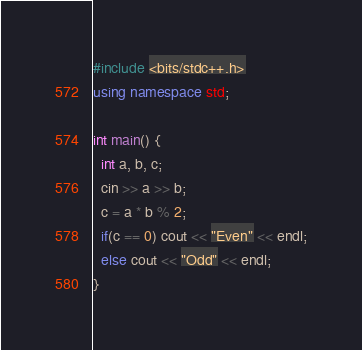<code> <loc_0><loc_0><loc_500><loc_500><_C++_>#include <bits/stdc++.h>
using namespace std;

int main() {
  int a, b, c;
  cin >> a >> b;
  c = a * b % 2;
  if(c == 0) cout << "Even" << endl;
  else cout << "Odd" << endl;
}</code> 